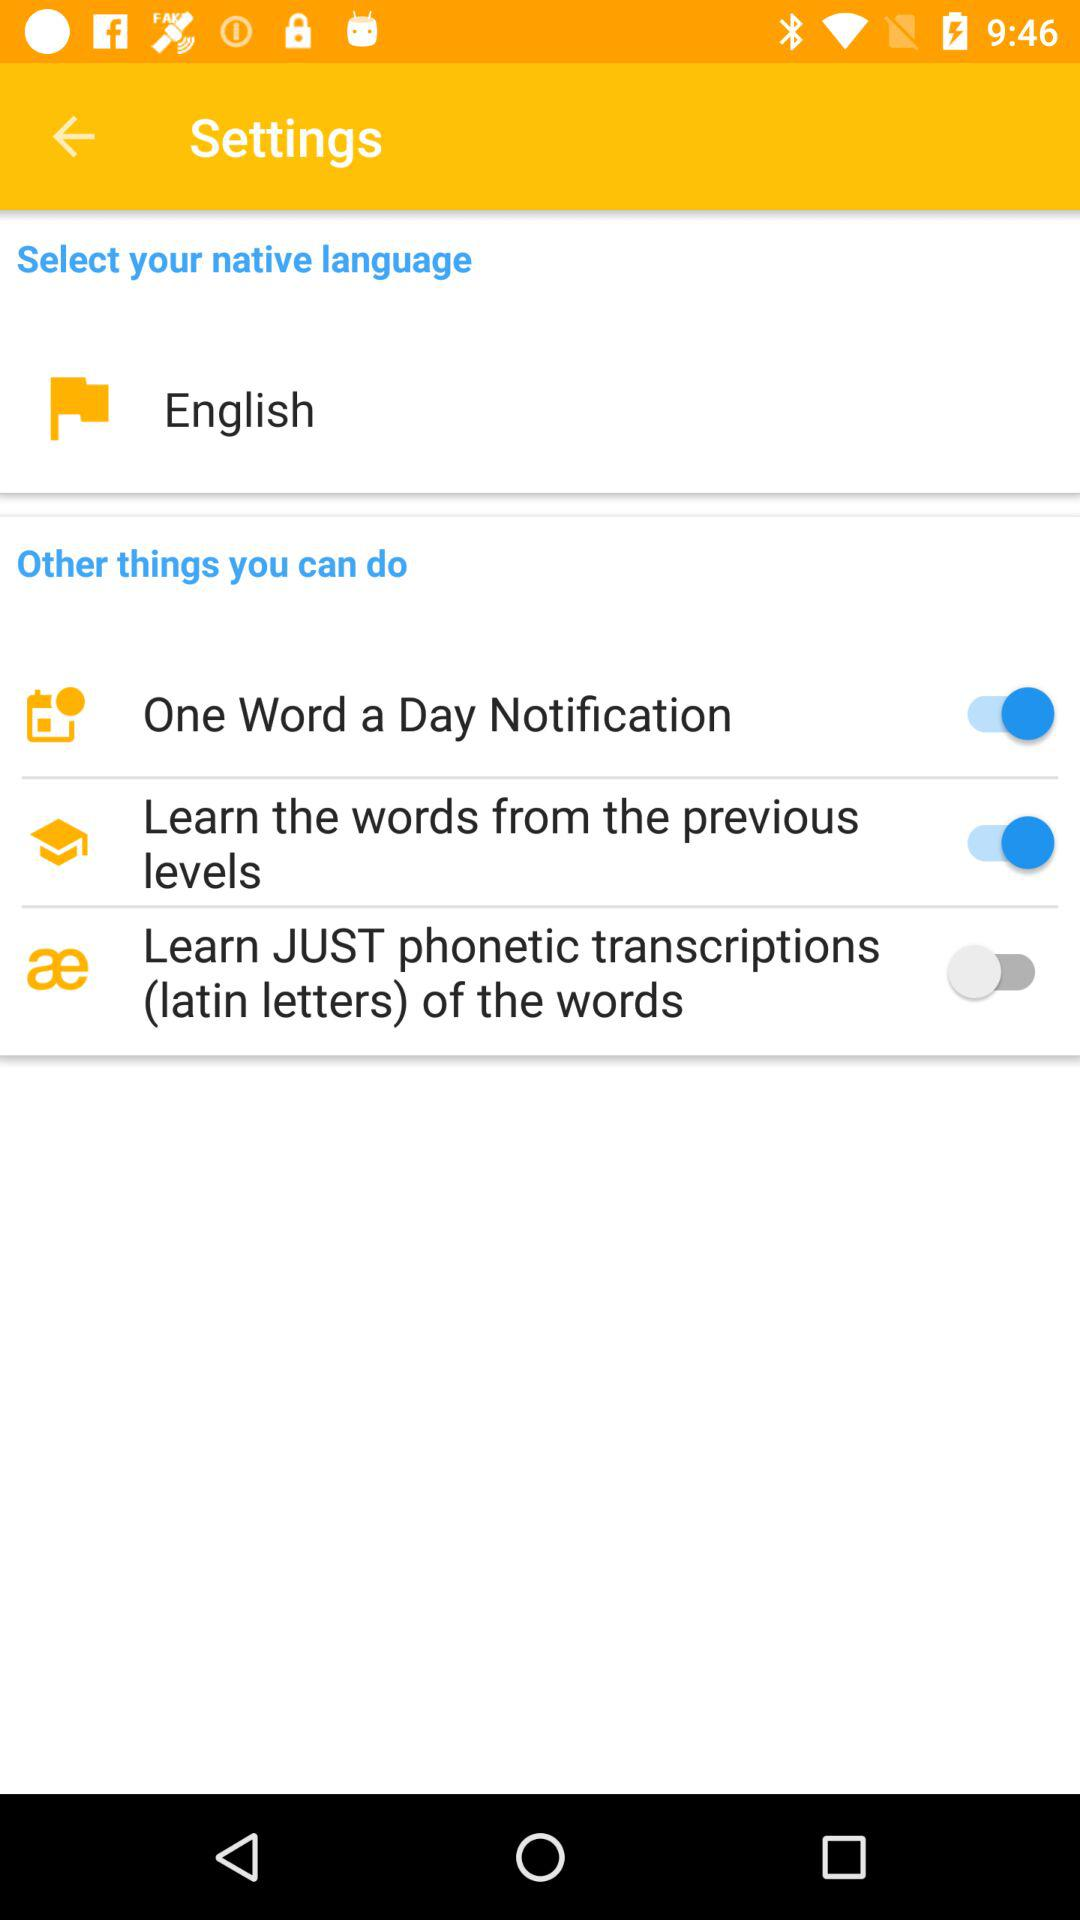How many of the items have a switch?
Answer the question using a single word or phrase. 3 